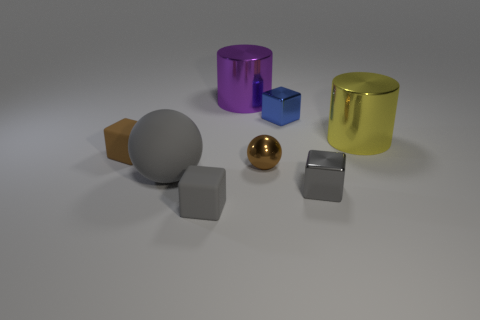If these objects were part of a learning exercise for children, what could be the educational purpose? These objects could be used to teach children about shapes, colors, and sizes. For instance, children could be asked to identify the different geometric forms, such as spheres, cubes, and cylinders, or arrange the objects by size or color spectrum. 